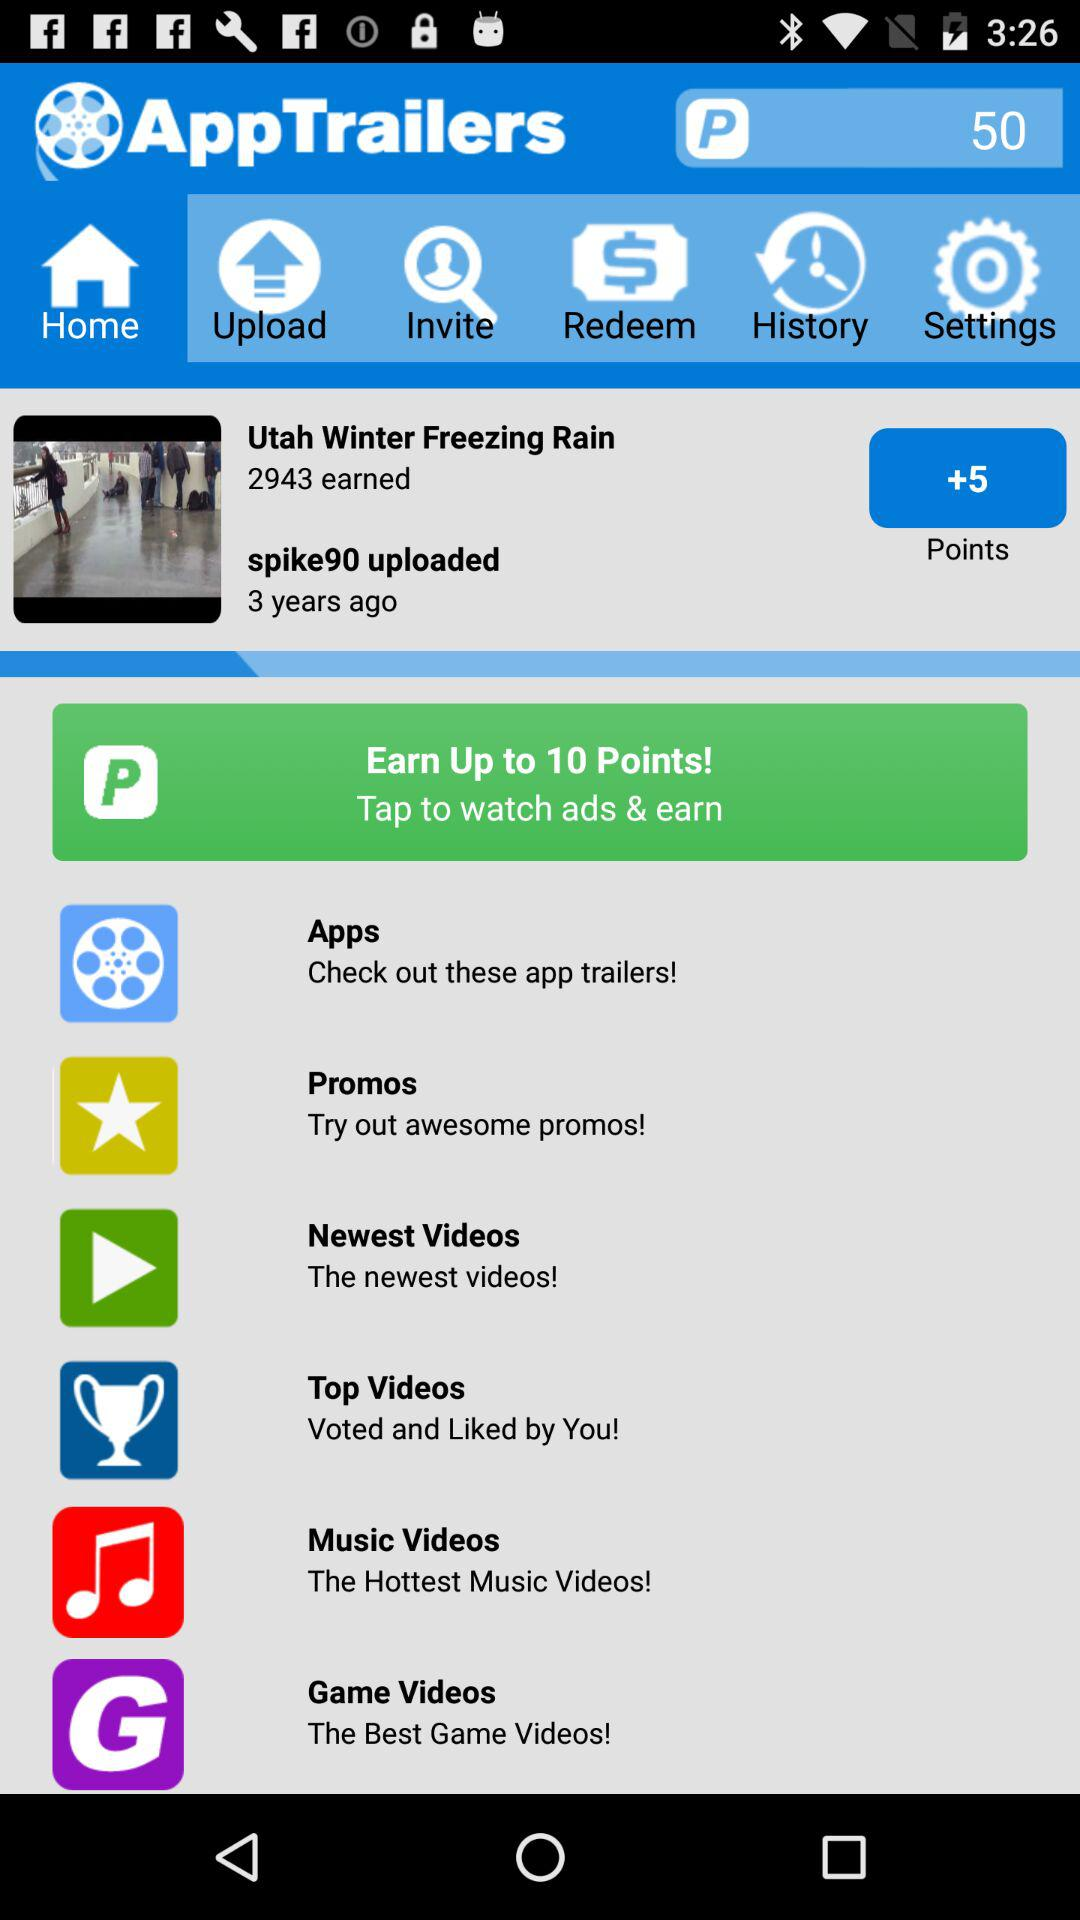How old is Spike 90 uploaded? The Spike was uploaded 3 years ago. 